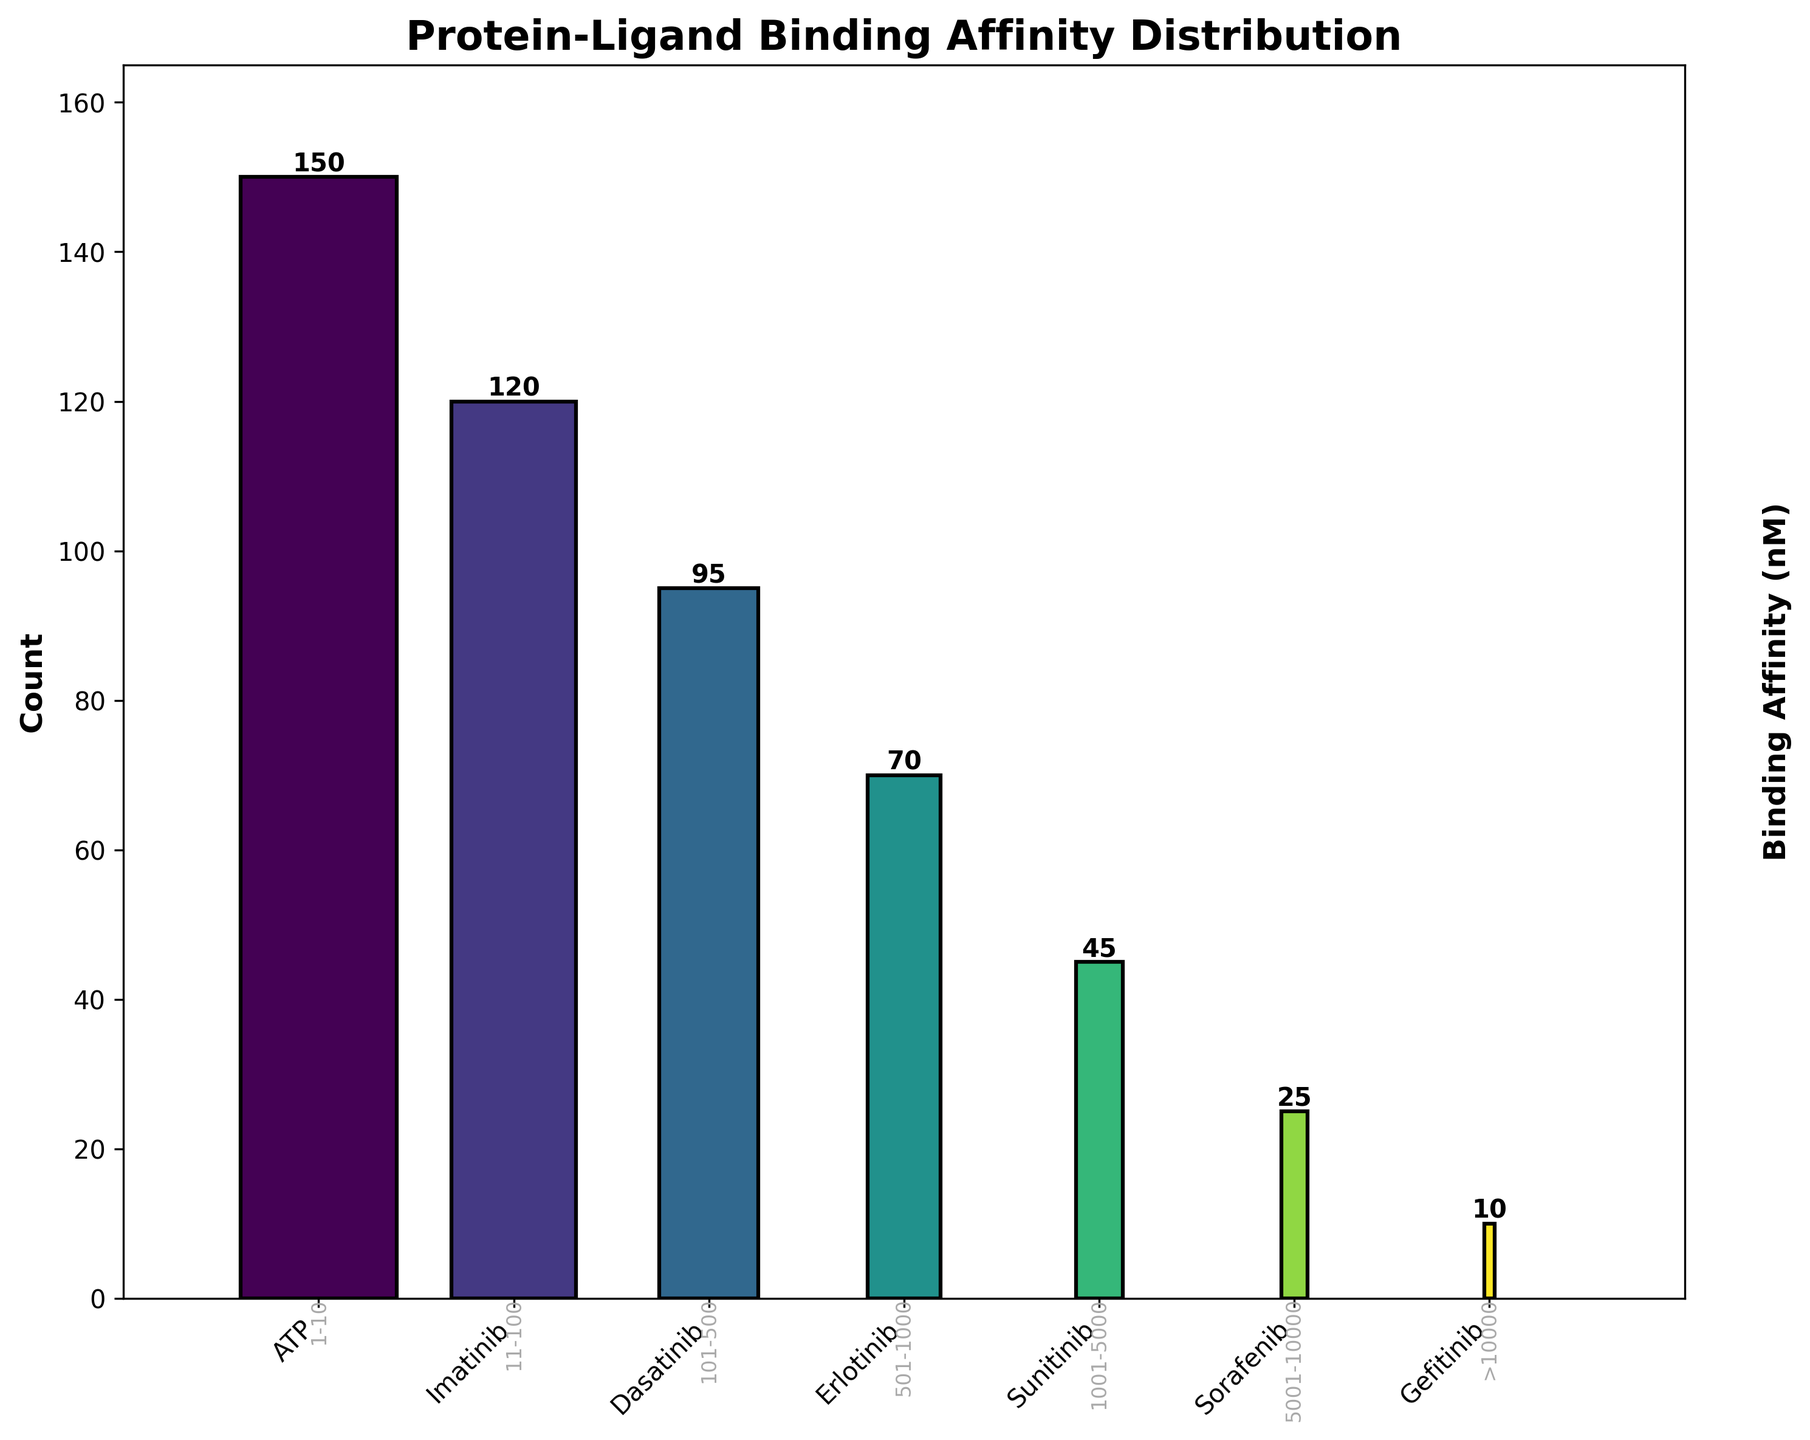What is the title of the plot? The title is placed prominently at the top of the plot and reads 'Protein-Ligand Binding Affinity Distribution'
Answer: Protein-Ligand Binding Affinity Distribution How many small molecules are represented in the plot? The plot shows separate bars for each small molecule, with distinct labels at the bottom: ATP, Imatinib, Dasatinib, Erlotinib, Sunitinib, Sorafenib, and Gefitinib. Counting these labels gives us the total number of small molecules.
Answer: 7 Which small molecule has the highest count? By looking at the height of the bars in the plot, we can see that ATP has the tallest bar, indicating the highest count.
Answer: ATP What is the binding affinity range for Sorafenib? The affinity range numbers are displayed at the base of the bars on the x-axis. The bar corresponding to Sorafenib is labeled with '5001-10000', indicating its binding affinity range.
Answer: 5001-10000 nM How many molecules have a count greater than 50? By inspecting the heights of each bar and the corresponding count labels, we see that ATP (150), Imatinib (120), and Dasatinib (95) all have counts greater than 50.
Answer: 3 What is the total count of all small molecules represented? To find the total, sum up the count labels on top of each bar: 150 (ATP) + 120 (Imatinib) + 95 (Dasatinib) + 70 (Erlotinib) + 45 (Sunitinib) + 25 (Sorafenib) + 10 (Gefitinib). This is calculated as 150 + 120 + 95 + 70 + 45 + 25 + 10 = 515.
Answer: 515 Which small molecule has the lowest binding affinity range? The lowest binding affinity range is '1-10', which, according to the labels at the base of the bars, corresponds to ATP.
Answer: ATP What is the ratio of the molecule with the highest count to the molecule with the lowest count? The highest count is 150 for ATP and the lowest count is 10 for Gefitinib. The ratio can be calculated as 150/10.
Answer: 15:1 What is the difference in count between Dasatinib and Sunitinib? The counts for Dasatinib and Sunitinib are 95 and 45, respectively. The difference is calculated as 95 - 45.
Answer: 50 Among the small molecules, which ones have binding affinities greater than 1000 nM? The small molecules with binding affinities in the ranges '>10000', '5001-10000', '1001-5000' on the x-axis labels are Gefitinib, Sorafenib, and Sunitinib.
Answer: Gefitinib, Sorafenib, and Sunitinib 